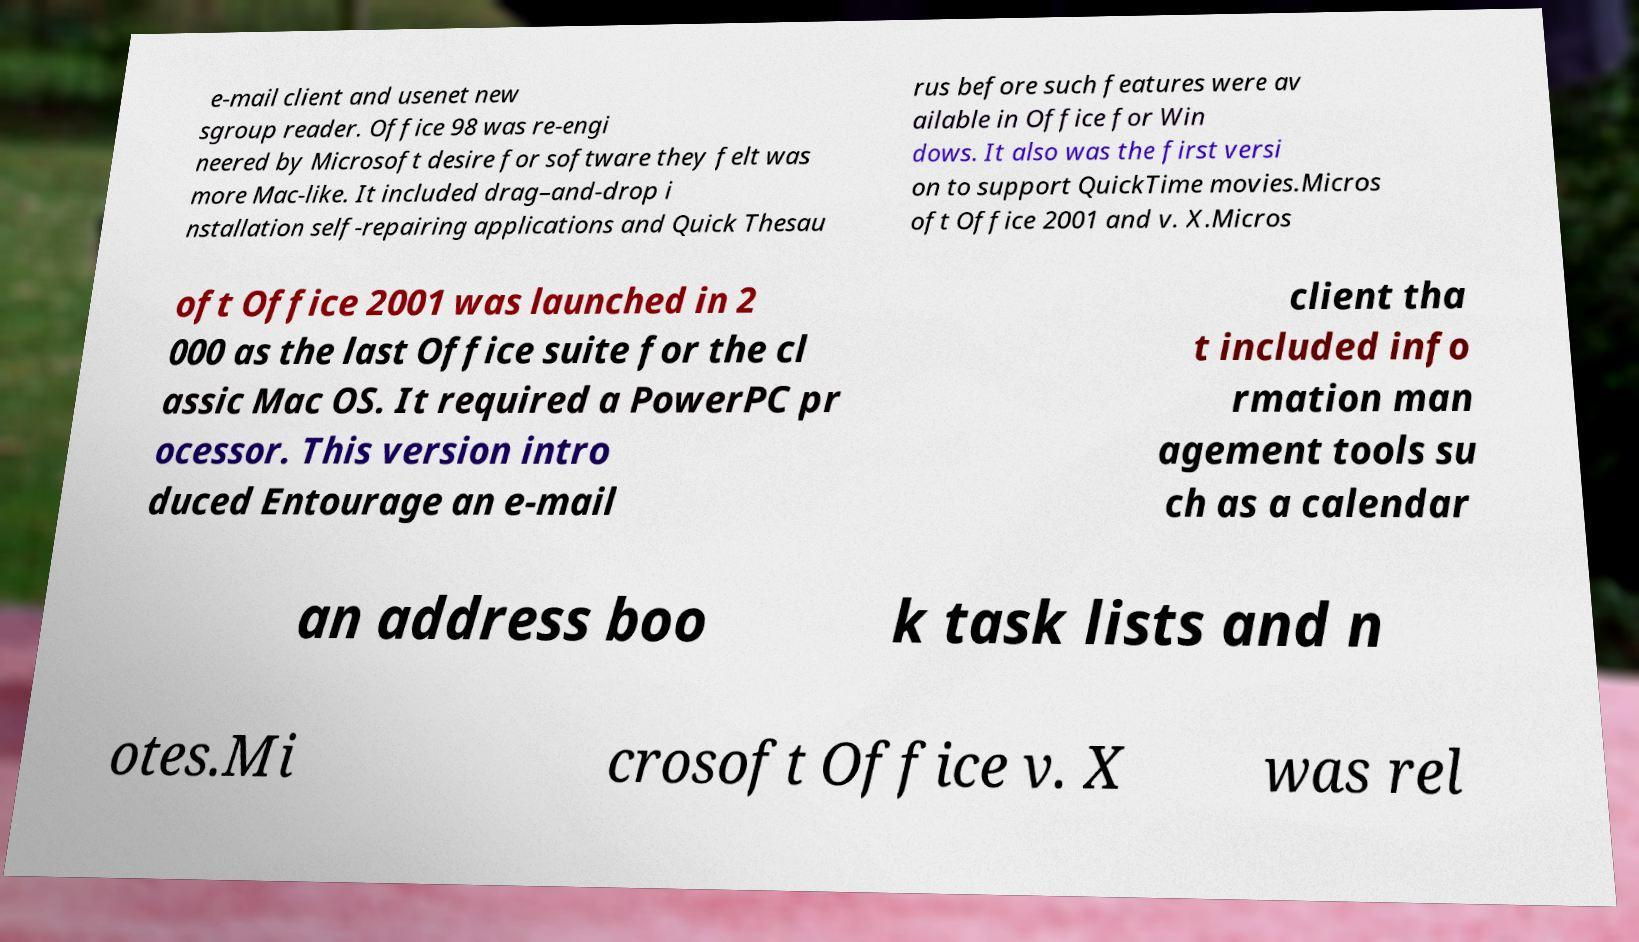Could you assist in decoding the text presented in this image and type it out clearly? e-mail client and usenet new sgroup reader. Office 98 was re-engi neered by Microsoft desire for software they felt was more Mac-like. It included drag–and-drop i nstallation self-repairing applications and Quick Thesau rus before such features were av ailable in Office for Win dows. It also was the first versi on to support QuickTime movies.Micros oft Office 2001 and v. X.Micros oft Office 2001 was launched in 2 000 as the last Office suite for the cl assic Mac OS. It required a PowerPC pr ocessor. This version intro duced Entourage an e-mail client tha t included info rmation man agement tools su ch as a calendar an address boo k task lists and n otes.Mi crosoft Office v. X was rel 